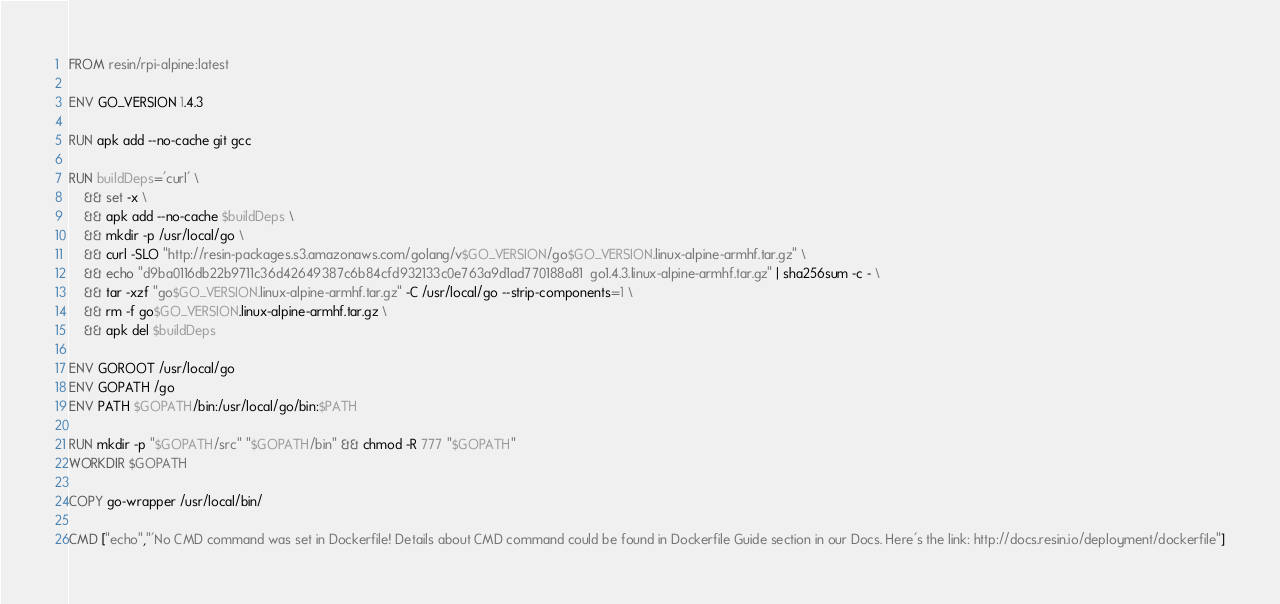<code> <loc_0><loc_0><loc_500><loc_500><_Dockerfile_>FROM resin/rpi-alpine:latest

ENV GO_VERSION 1.4.3

RUN apk add --no-cache git gcc

RUN buildDeps='curl' \
	&& set -x \
	&& apk add --no-cache $buildDeps \
	&& mkdir -p /usr/local/go \
	&& curl -SLO "http://resin-packages.s3.amazonaws.com/golang/v$GO_VERSION/go$GO_VERSION.linux-alpine-armhf.tar.gz" \
	&& echo "d9ba0116db22b9711c36d42649387c6b84cfd932133c0e763a9d1ad770188a81  go1.4.3.linux-alpine-armhf.tar.gz" | sha256sum -c - \
	&& tar -xzf "go$GO_VERSION.linux-alpine-armhf.tar.gz" -C /usr/local/go --strip-components=1 \
	&& rm -f go$GO_VERSION.linux-alpine-armhf.tar.gz \
	&& apk del $buildDeps

ENV GOROOT /usr/local/go
ENV GOPATH /go
ENV PATH $GOPATH/bin:/usr/local/go/bin:$PATH

RUN mkdir -p "$GOPATH/src" "$GOPATH/bin" && chmod -R 777 "$GOPATH"
WORKDIR $GOPATH

COPY go-wrapper /usr/local/bin/

CMD ["echo","'No CMD command was set in Dockerfile! Details about CMD command could be found in Dockerfile Guide section in our Docs. Here's the link: http://docs.resin.io/deployment/dockerfile"]
</code> 